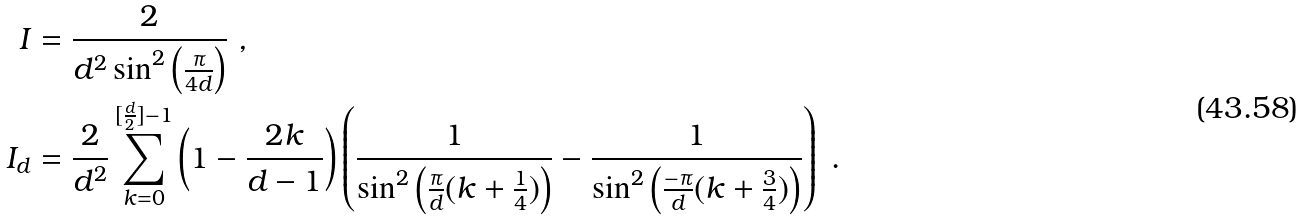<formula> <loc_0><loc_0><loc_500><loc_500>I & = \frac { 2 } { d ^ { 2 } \sin ^ { 2 } \left ( \frac { \pi } { 4 d } \right ) } \ , \\ I _ { d } & = \frac { 2 } { d ^ { 2 } } \sum _ { k = 0 } ^ { [ \frac { d } { 2 } ] - 1 } \left ( 1 - \frac { 2 k } { d - 1 } \right ) \left ( \frac { 1 } { \sin ^ { 2 } \left ( \frac { \pi } { d } ( k + \frac { 1 } { 4 } ) \right ) } - \frac { 1 } { \sin ^ { 2 } \left ( \frac { - \pi } { d } ( k + \frac { 3 } { 4 } ) \right ) } \right ) \ .</formula> 